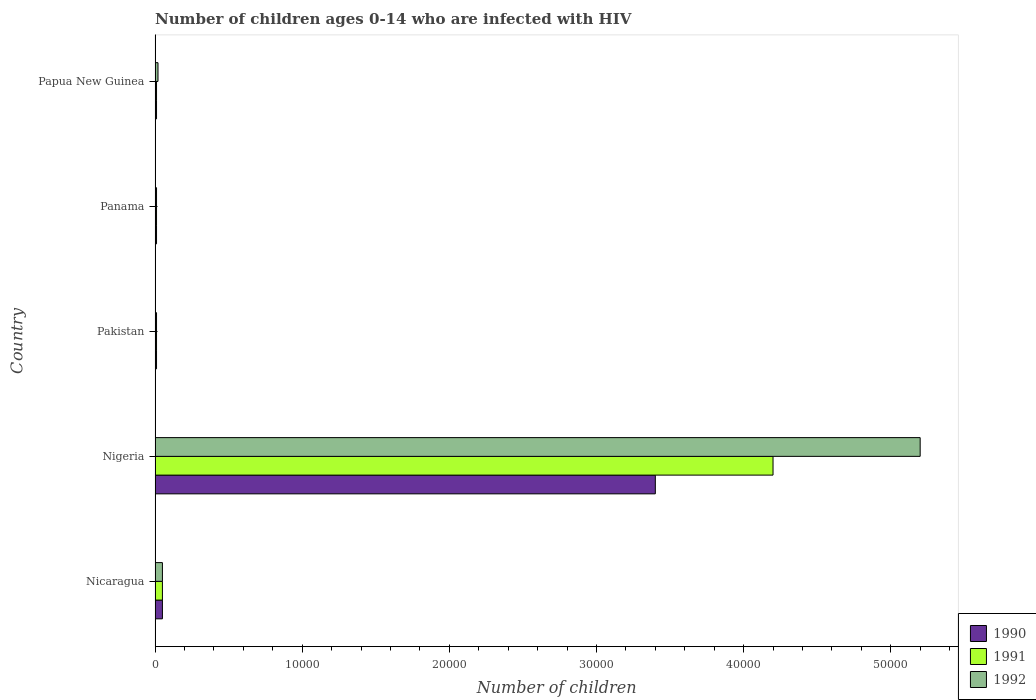How many different coloured bars are there?
Provide a short and direct response. 3. How many groups of bars are there?
Keep it short and to the point. 5. Are the number of bars per tick equal to the number of legend labels?
Your answer should be very brief. Yes. Are the number of bars on each tick of the Y-axis equal?
Make the answer very short. Yes. How many bars are there on the 1st tick from the top?
Provide a succinct answer. 3. What is the label of the 4th group of bars from the top?
Make the answer very short. Nigeria. What is the number of HIV infected children in 1990 in Pakistan?
Make the answer very short. 100. Across all countries, what is the maximum number of HIV infected children in 1992?
Offer a very short reply. 5.20e+04. Across all countries, what is the minimum number of HIV infected children in 1992?
Your answer should be compact. 100. In which country was the number of HIV infected children in 1992 maximum?
Keep it short and to the point. Nigeria. What is the total number of HIV infected children in 1992 in the graph?
Your response must be concise. 5.29e+04. What is the difference between the number of HIV infected children in 1990 in Panama and the number of HIV infected children in 1991 in Nigeria?
Provide a succinct answer. -4.19e+04. What is the average number of HIV infected children in 1991 per country?
Make the answer very short. 8560. What is the difference between the number of HIV infected children in 1990 and number of HIV infected children in 1992 in Nigeria?
Offer a very short reply. -1.80e+04. What is the ratio of the number of HIV infected children in 1991 in Nicaragua to that in Nigeria?
Provide a succinct answer. 0.01. What is the difference between the highest and the second highest number of HIV infected children in 1990?
Offer a terse response. 3.35e+04. What is the difference between the highest and the lowest number of HIV infected children in 1992?
Make the answer very short. 5.19e+04. In how many countries, is the number of HIV infected children in 1990 greater than the average number of HIV infected children in 1990 taken over all countries?
Provide a short and direct response. 1. What does the 3rd bar from the bottom in Pakistan represents?
Provide a short and direct response. 1992. Is it the case that in every country, the sum of the number of HIV infected children in 1991 and number of HIV infected children in 1990 is greater than the number of HIV infected children in 1992?
Your response must be concise. No. Are all the bars in the graph horizontal?
Keep it short and to the point. Yes. What is the difference between two consecutive major ticks on the X-axis?
Offer a very short reply. 10000. Are the values on the major ticks of X-axis written in scientific E-notation?
Ensure brevity in your answer.  No. Does the graph contain grids?
Your answer should be very brief. No. How many legend labels are there?
Keep it short and to the point. 3. How are the legend labels stacked?
Your response must be concise. Vertical. What is the title of the graph?
Give a very brief answer. Number of children ages 0-14 who are infected with HIV. What is the label or title of the X-axis?
Give a very brief answer. Number of children. What is the Number of children of 1990 in Nicaragua?
Ensure brevity in your answer.  500. What is the Number of children in 1991 in Nicaragua?
Give a very brief answer. 500. What is the Number of children of 1992 in Nicaragua?
Provide a short and direct response. 500. What is the Number of children of 1990 in Nigeria?
Offer a terse response. 3.40e+04. What is the Number of children in 1991 in Nigeria?
Your response must be concise. 4.20e+04. What is the Number of children in 1992 in Nigeria?
Your answer should be compact. 5.20e+04. What is the Number of children in 1991 in Pakistan?
Your answer should be very brief. 100. What is the Number of children of 1991 in Panama?
Give a very brief answer. 100. What is the Number of children of 1990 in Papua New Guinea?
Make the answer very short. 100. Across all countries, what is the maximum Number of children of 1990?
Offer a very short reply. 3.40e+04. Across all countries, what is the maximum Number of children of 1991?
Give a very brief answer. 4.20e+04. Across all countries, what is the maximum Number of children in 1992?
Your response must be concise. 5.20e+04. Across all countries, what is the minimum Number of children of 1990?
Give a very brief answer. 100. Across all countries, what is the minimum Number of children of 1991?
Ensure brevity in your answer.  100. What is the total Number of children of 1990 in the graph?
Make the answer very short. 3.48e+04. What is the total Number of children in 1991 in the graph?
Your response must be concise. 4.28e+04. What is the total Number of children in 1992 in the graph?
Provide a succinct answer. 5.29e+04. What is the difference between the Number of children of 1990 in Nicaragua and that in Nigeria?
Keep it short and to the point. -3.35e+04. What is the difference between the Number of children in 1991 in Nicaragua and that in Nigeria?
Your answer should be compact. -4.15e+04. What is the difference between the Number of children of 1992 in Nicaragua and that in Nigeria?
Offer a very short reply. -5.15e+04. What is the difference between the Number of children in 1991 in Nicaragua and that in Pakistan?
Keep it short and to the point. 400. What is the difference between the Number of children in 1992 in Nicaragua and that in Pakistan?
Your answer should be compact. 400. What is the difference between the Number of children of 1992 in Nicaragua and that in Panama?
Ensure brevity in your answer.  400. What is the difference between the Number of children in 1990 in Nicaragua and that in Papua New Guinea?
Your answer should be compact. 400. What is the difference between the Number of children of 1992 in Nicaragua and that in Papua New Guinea?
Keep it short and to the point. 300. What is the difference between the Number of children in 1990 in Nigeria and that in Pakistan?
Your answer should be very brief. 3.39e+04. What is the difference between the Number of children in 1991 in Nigeria and that in Pakistan?
Provide a succinct answer. 4.19e+04. What is the difference between the Number of children of 1992 in Nigeria and that in Pakistan?
Your answer should be very brief. 5.19e+04. What is the difference between the Number of children in 1990 in Nigeria and that in Panama?
Your answer should be very brief. 3.39e+04. What is the difference between the Number of children in 1991 in Nigeria and that in Panama?
Provide a short and direct response. 4.19e+04. What is the difference between the Number of children in 1992 in Nigeria and that in Panama?
Give a very brief answer. 5.19e+04. What is the difference between the Number of children in 1990 in Nigeria and that in Papua New Guinea?
Offer a terse response. 3.39e+04. What is the difference between the Number of children of 1991 in Nigeria and that in Papua New Guinea?
Keep it short and to the point. 4.19e+04. What is the difference between the Number of children in 1992 in Nigeria and that in Papua New Guinea?
Offer a very short reply. 5.18e+04. What is the difference between the Number of children of 1990 in Pakistan and that in Panama?
Provide a short and direct response. 0. What is the difference between the Number of children in 1990 in Pakistan and that in Papua New Guinea?
Provide a succinct answer. 0. What is the difference between the Number of children of 1991 in Pakistan and that in Papua New Guinea?
Offer a very short reply. 0. What is the difference between the Number of children of 1992 in Pakistan and that in Papua New Guinea?
Provide a short and direct response. -100. What is the difference between the Number of children of 1990 in Panama and that in Papua New Guinea?
Give a very brief answer. 0. What is the difference between the Number of children of 1992 in Panama and that in Papua New Guinea?
Ensure brevity in your answer.  -100. What is the difference between the Number of children in 1990 in Nicaragua and the Number of children in 1991 in Nigeria?
Keep it short and to the point. -4.15e+04. What is the difference between the Number of children in 1990 in Nicaragua and the Number of children in 1992 in Nigeria?
Provide a short and direct response. -5.15e+04. What is the difference between the Number of children of 1991 in Nicaragua and the Number of children of 1992 in Nigeria?
Offer a very short reply. -5.15e+04. What is the difference between the Number of children in 1990 in Nicaragua and the Number of children in 1991 in Pakistan?
Provide a short and direct response. 400. What is the difference between the Number of children of 1990 in Nicaragua and the Number of children of 1992 in Pakistan?
Offer a very short reply. 400. What is the difference between the Number of children in 1991 in Nicaragua and the Number of children in 1992 in Pakistan?
Ensure brevity in your answer.  400. What is the difference between the Number of children of 1990 in Nicaragua and the Number of children of 1991 in Panama?
Give a very brief answer. 400. What is the difference between the Number of children of 1990 in Nicaragua and the Number of children of 1991 in Papua New Guinea?
Provide a short and direct response. 400. What is the difference between the Number of children in 1990 in Nicaragua and the Number of children in 1992 in Papua New Guinea?
Provide a short and direct response. 300. What is the difference between the Number of children in 1991 in Nicaragua and the Number of children in 1992 in Papua New Guinea?
Offer a very short reply. 300. What is the difference between the Number of children of 1990 in Nigeria and the Number of children of 1991 in Pakistan?
Keep it short and to the point. 3.39e+04. What is the difference between the Number of children of 1990 in Nigeria and the Number of children of 1992 in Pakistan?
Give a very brief answer. 3.39e+04. What is the difference between the Number of children in 1991 in Nigeria and the Number of children in 1992 in Pakistan?
Your answer should be very brief. 4.19e+04. What is the difference between the Number of children of 1990 in Nigeria and the Number of children of 1991 in Panama?
Offer a terse response. 3.39e+04. What is the difference between the Number of children of 1990 in Nigeria and the Number of children of 1992 in Panama?
Make the answer very short. 3.39e+04. What is the difference between the Number of children in 1991 in Nigeria and the Number of children in 1992 in Panama?
Ensure brevity in your answer.  4.19e+04. What is the difference between the Number of children of 1990 in Nigeria and the Number of children of 1991 in Papua New Guinea?
Give a very brief answer. 3.39e+04. What is the difference between the Number of children of 1990 in Nigeria and the Number of children of 1992 in Papua New Guinea?
Your response must be concise. 3.38e+04. What is the difference between the Number of children of 1991 in Nigeria and the Number of children of 1992 in Papua New Guinea?
Offer a terse response. 4.18e+04. What is the difference between the Number of children of 1990 in Pakistan and the Number of children of 1991 in Panama?
Make the answer very short. 0. What is the difference between the Number of children in 1990 in Pakistan and the Number of children in 1992 in Papua New Guinea?
Give a very brief answer. -100. What is the difference between the Number of children in 1991 in Pakistan and the Number of children in 1992 in Papua New Guinea?
Your response must be concise. -100. What is the difference between the Number of children in 1990 in Panama and the Number of children in 1991 in Papua New Guinea?
Offer a very short reply. 0. What is the difference between the Number of children in 1990 in Panama and the Number of children in 1992 in Papua New Guinea?
Ensure brevity in your answer.  -100. What is the difference between the Number of children in 1991 in Panama and the Number of children in 1992 in Papua New Guinea?
Keep it short and to the point. -100. What is the average Number of children of 1990 per country?
Your response must be concise. 6960. What is the average Number of children of 1991 per country?
Your answer should be compact. 8560. What is the average Number of children in 1992 per country?
Make the answer very short. 1.06e+04. What is the difference between the Number of children in 1990 and Number of children in 1991 in Nicaragua?
Your answer should be very brief. 0. What is the difference between the Number of children in 1990 and Number of children in 1992 in Nicaragua?
Provide a short and direct response. 0. What is the difference between the Number of children of 1990 and Number of children of 1991 in Nigeria?
Provide a short and direct response. -8000. What is the difference between the Number of children in 1990 and Number of children in 1992 in Nigeria?
Provide a short and direct response. -1.80e+04. What is the difference between the Number of children of 1990 and Number of children of 1991 in Pakistan?
Give a very brief answer. 0. What is the difference between the Number of children of 1990 and Number of children of 1992 in Pakistan?
Give a very brief answer. 0. What is the difference between the Number of children of 1991 and Number of children of 1992 in Panama?
Your answer should be compact. 0. What is the difference between the Number of children in 1990 and Number of children in 1992 in Papua New Guinea?
Offer a very short reply. -100. What is the difference between the Number of children of 1991 and Number of children of 1992 in Papua New Guinea?
Offer a very short reply. -100. What is the ratio of the Number of children of 1990 in Nicaragua to that in Nigeria?
Give a very brief answer. 0.01. What is the ratio of the Number of children of 1991 in Nicaragua to that in Nigeria?
Provide a succinct answer. 0.01. What is the ratio of the Number of children of 1992 in Nicaragua to that in Nigeria?
Provide a succinct answer. 0.01. What is the ratio of the Number of children in 1990 in Nicaragua to that in Pakistan?
Your response must be concise. 5. What is the ratio of the Number of children in 1991 in Nicaragua to that in Panama?
Your answer should be compact. 5. What is the ratio of the Number of children in 1990 in Nicaragua to that in Papua New Guinea?
Provide a succinct answer. 5. What is the ratio of the Number of children of 1992 in Nicaragua to that in Papua New Guinea?
Make the answer very short. 2.5. What is the ratio of the Number of children in 1990 in Nigeria to that in Pakistan?
Ensure brevity in your answer.  340. What is the ratio of the Number of children in 1991 in Nigeria to that in Pakistan?
Offer a very short reply. 420. What is the ratio of the Number of children of 1992 in Nigeria to that in Pakistan?
Provide a succinct answer. 520. What is the ratio of the Number of children of 1990 in Nigeria to that in Panama?
Ensure brevity in your answer.  340. What is the ratio of the Number of children of 1991 in Nigeria to that in Panama?
Make the answer very short. 420. What is the ratio of the Number of children in 1992 in Nigeria to that in Panama?
Offer a terse response. 520. What is the ratio of the Number of children of 1990 in Nigeria to that in Papua New Guinea?
Your answer should be compact. 340. What is the ratio of the Number of children of 1991 in Nigeria to that in Papua New Guinea?
Your answer should be very brief. 420. What is the ratio of the Number of children of 1992 in Nigeria to that in Papua New Guinea?
Keep it short and to the point. 260. What is the ratio of the Number of children in 1990 in Pakistan to that in Panama?
Offer a terse response. 1. What is the ratio of the Number of children of 1991 in Pakistan to that in Panama?
Provide a succinct answer. 1. What is the ratio of the Number of children of 1992 in Pakistan to that in Panama?
Your answer should be compact. 1. What is the ratio of the Number of children of 1992 in Panama to that in Papua New Guinea?
Give a very brief answer. 0.5. What is the difference between the highest and the second highest Number of children in 1990?
Ensure brevity in your answer.  3.35e+04. What is the difference between the highest and the second highest Number of children of 1991?
Provide a short and direct response. 4.15e+04. What is the difference between the highest and the second highest Number of children in 1992?
Keep it short and to the point. 5.15e+04. What is the difference between the highest and the lowest Number of children of 1990?
Your answer should be compact. 3.39e+04. What is the difference between the highest and the lowest Number of children of 1991?
Keep it short and to the point. 4.19e+04. What is the difference between the highest and the lowest Number of children of 1992?
Ensure brevity in your answer.  5.19e+04. 